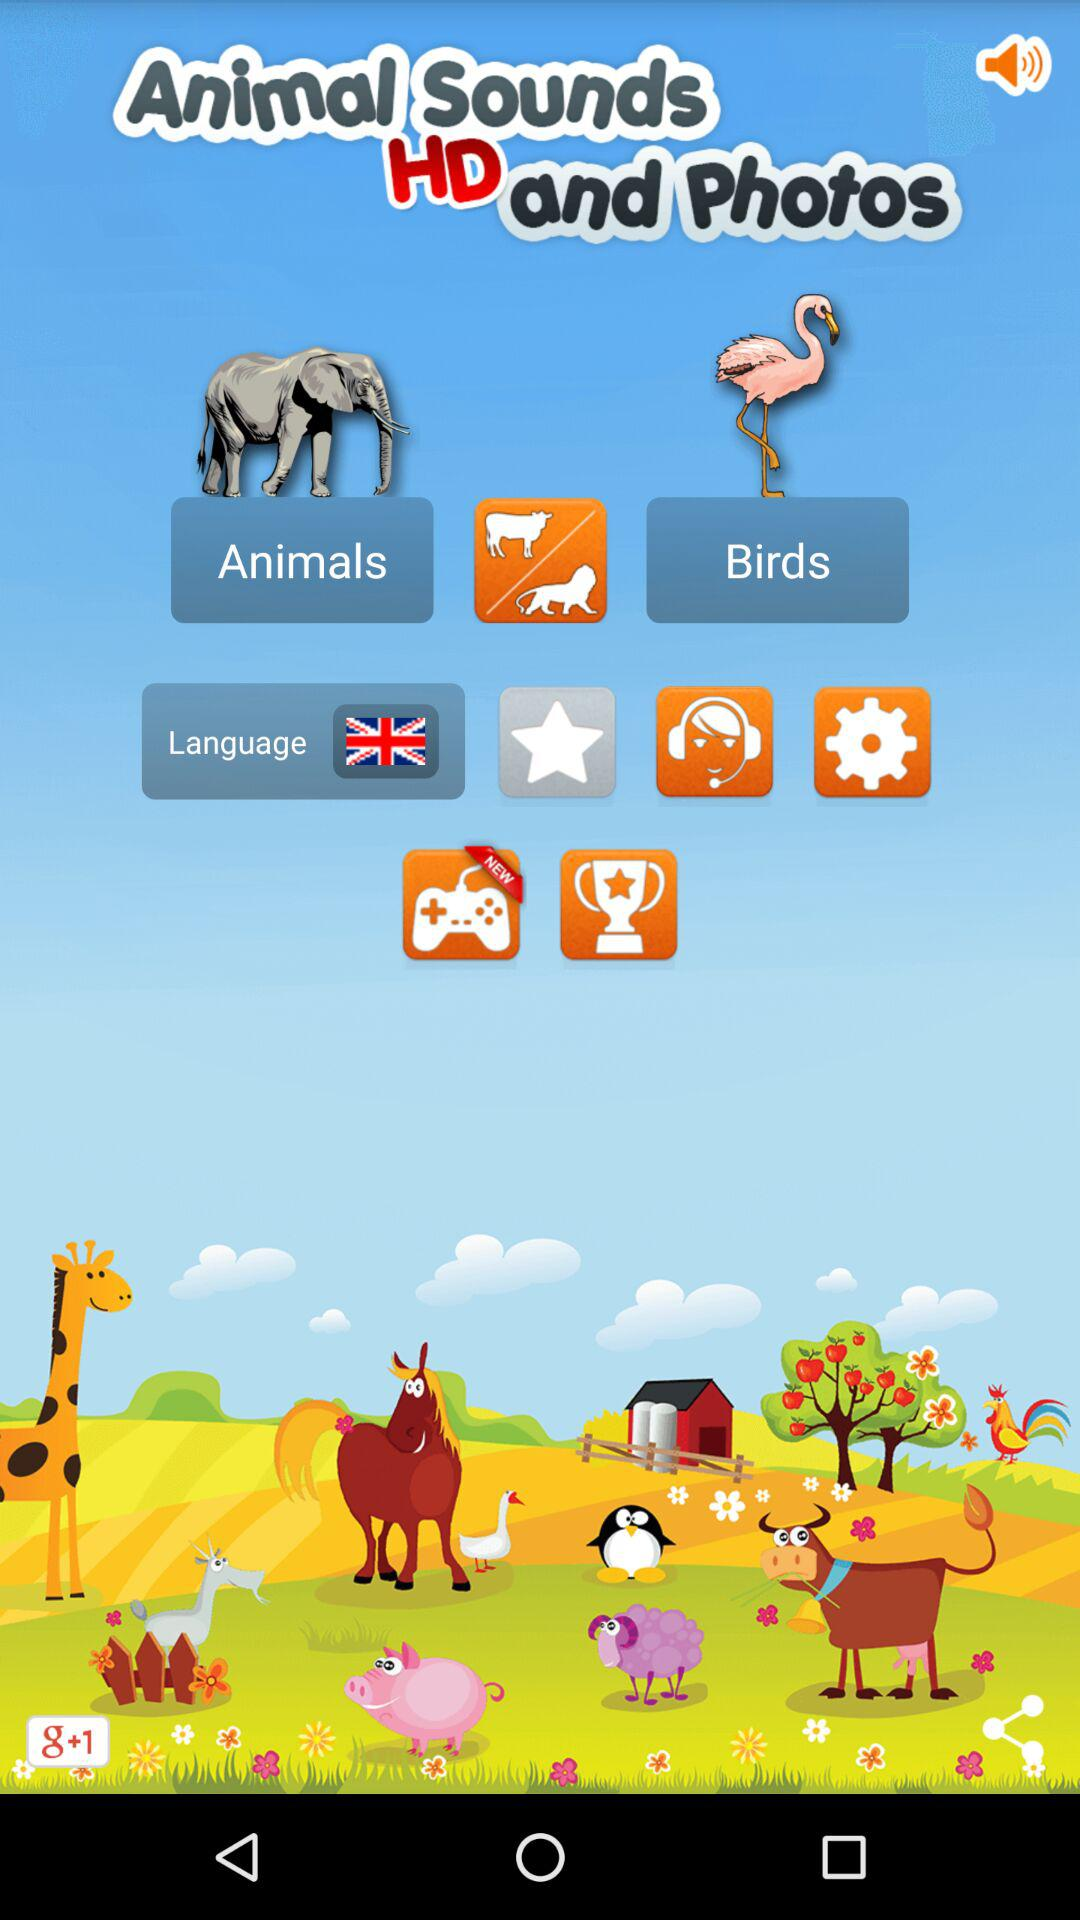Which options are in the settings?
When the provided information is insufficient, respond with <no answer>. <no answer> 